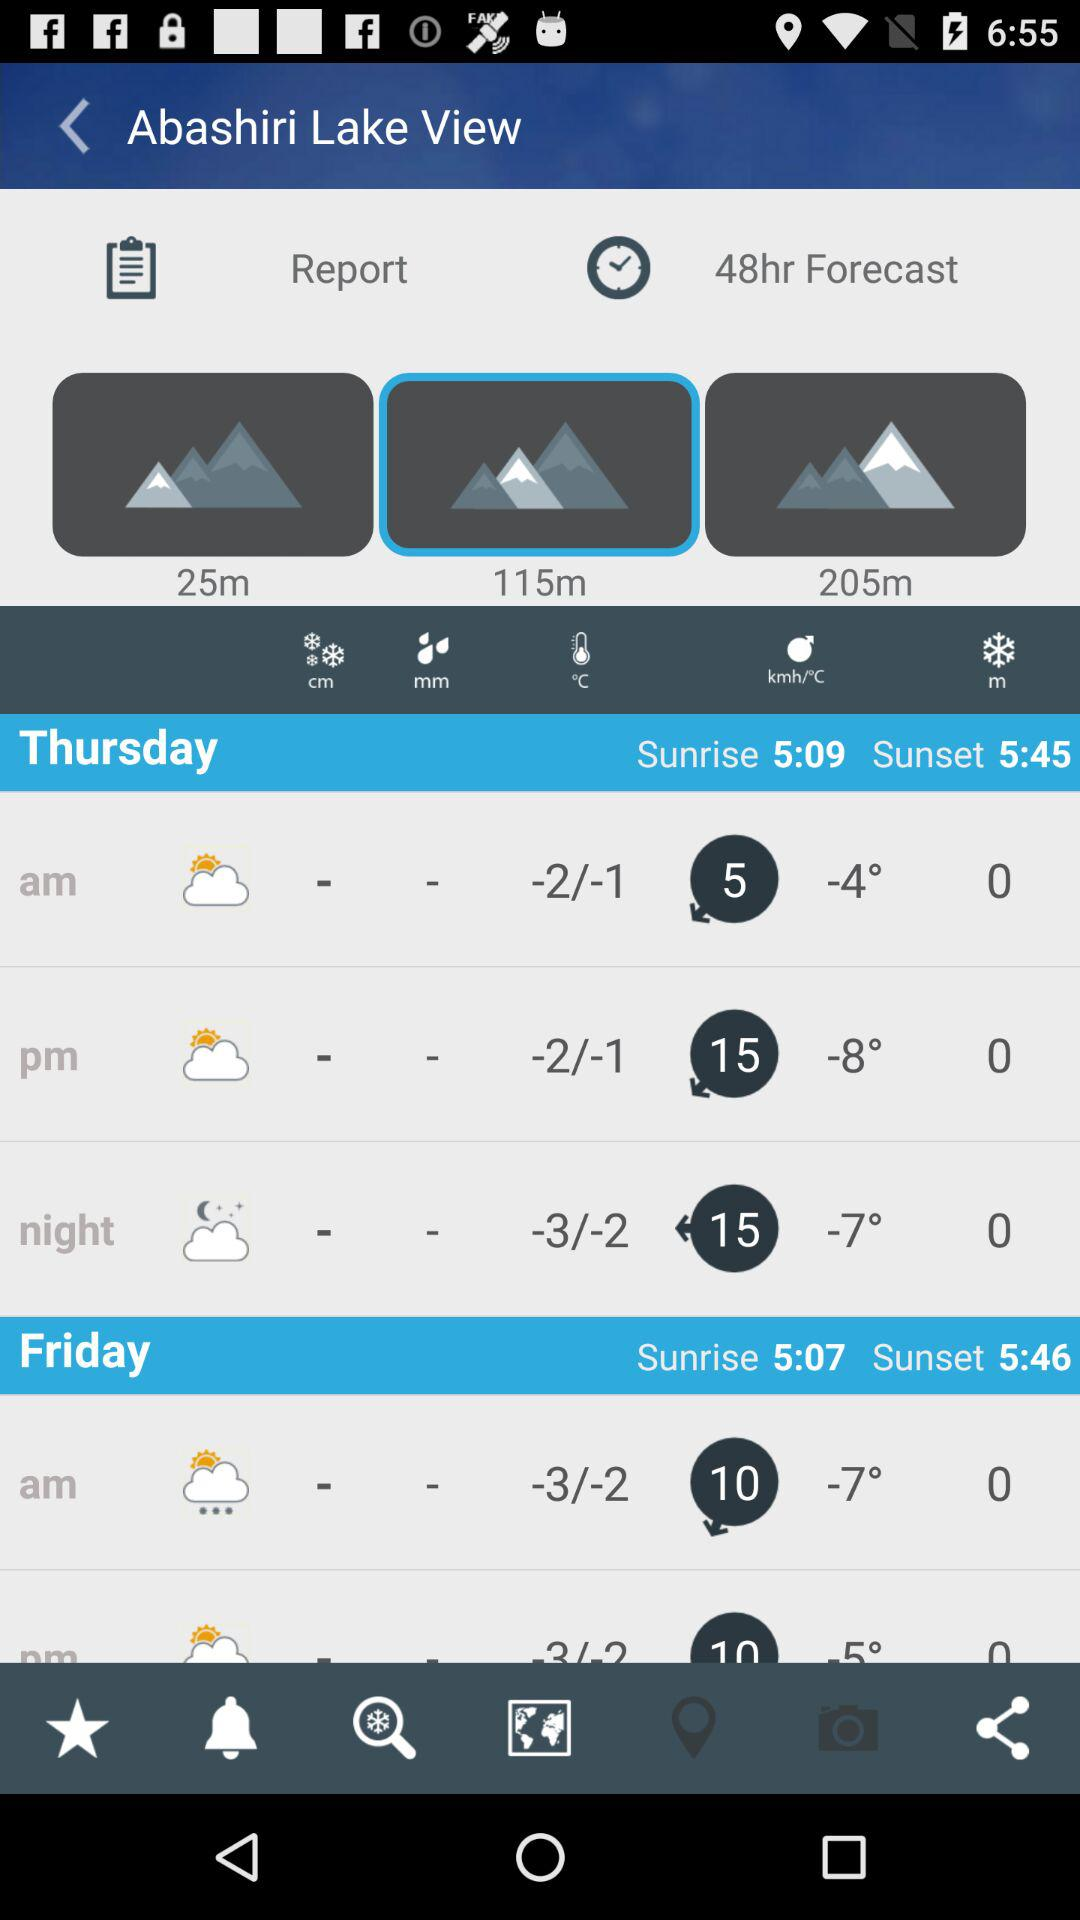What is the sunrise time on Friday? The sunrise time on Friday is 5:07. 